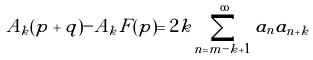Convert formula to latex. <formula><loc_0><loc_0><loc_500><loc_500>A _ { k } ( p + q ) - A _ { k } F ( p ) = 2 k \sum _ { n = m - k + 1 } ^ { \infty } a _ { n } a _ { n + k }</formula> 